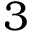Convert formula to latex. <formula><loc_0><loc_0><loc_500><loc_500>3</formula> 